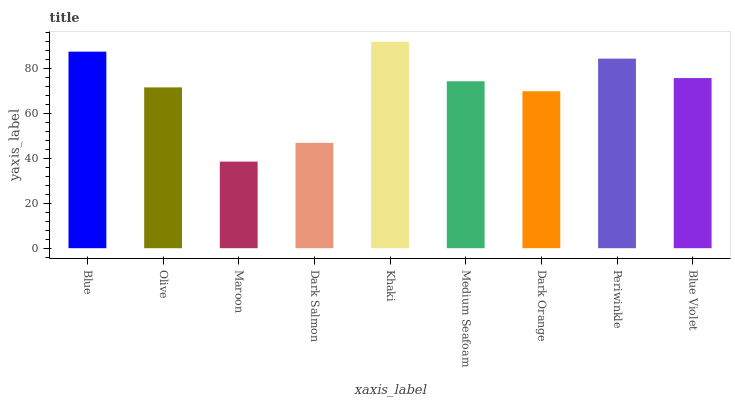Is Maroon the minimum?
Answer yes or no. Yes. Is Khaki the maximum?
Answer yes or no. Yes. Is Olive the minimum?
Answer yes or no. No. Is Olive the maximum?
Answer yes or no. No. Is Blue greater than Olive?
Answer yes or no. Yes. Is Olive less than Blue?
Answer yes or no. Yes. Is Olive greater than Blue?
Answer yes or no. No. Is Blue less than Olive?
Answer yes or no. No. Is Medium Seafoam the high median?
Answer yes or no. Yes. Is Medium Seafoam the low median?
Answer yes or no. Yes. Is Blue the high median?
Answer yes or no. No. Is Dark Orange the low median?
Answer yes or no. No. 